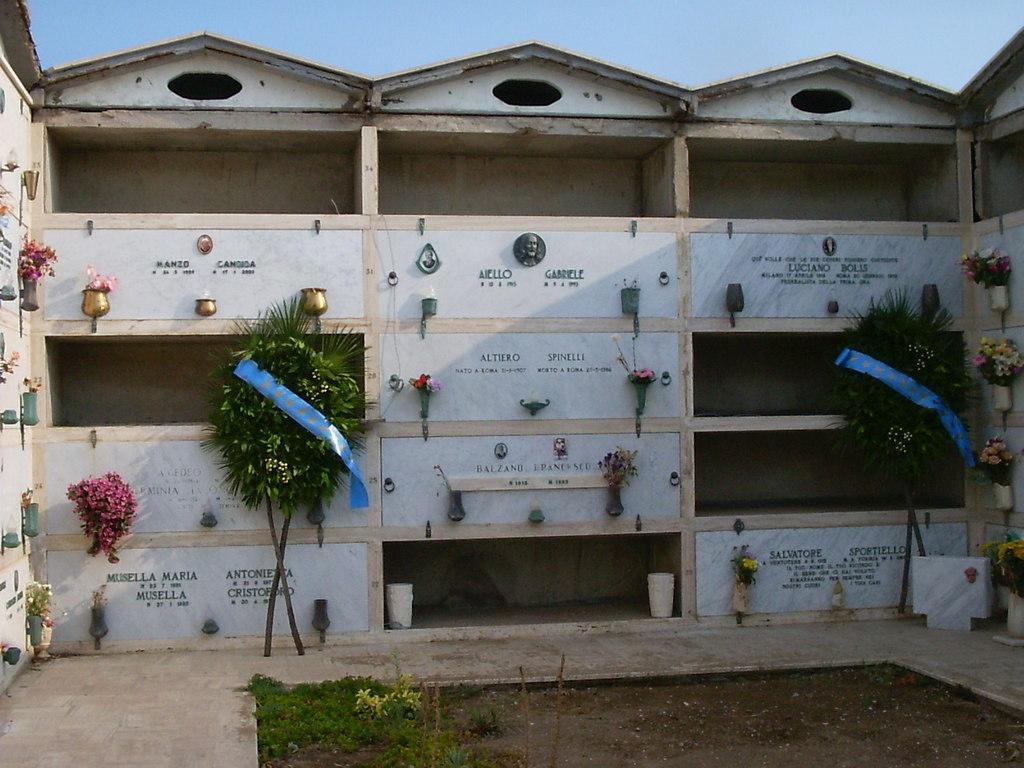Can you describe this image briefly? This picture might be taken from outside of the building. In this image, on the right side, we can see a tree, flower pot and plant with some flowers. On the left side, we can also see a tree, plant with some flowers. In the background, we can see a building, at the top, we can see a sky, at the bottom, we can see a grass and a land with some stones. 